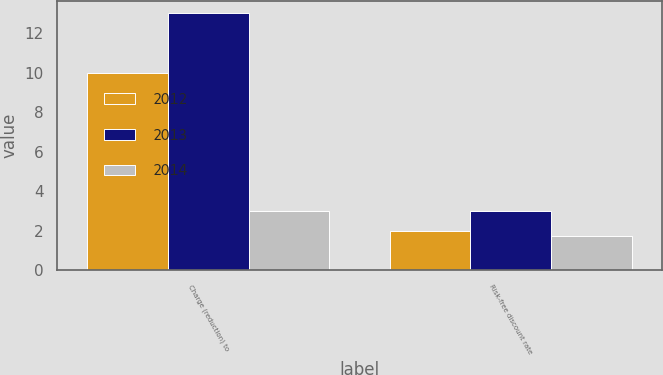Convert chart to OTSL. <chart><loc_0><loc_0><loc_500><loc_500><stacked_bar_chart><ecel><fcel>Charge (reduction) to<fcel>Risk-free discount rate<nl><fcel>2012<fcel>10<fcel>2<nl><fcel>2013<fcel>13<fcel>3<nl><fcel>2014<fcel>3<fcel>1.75<nl></chart> 